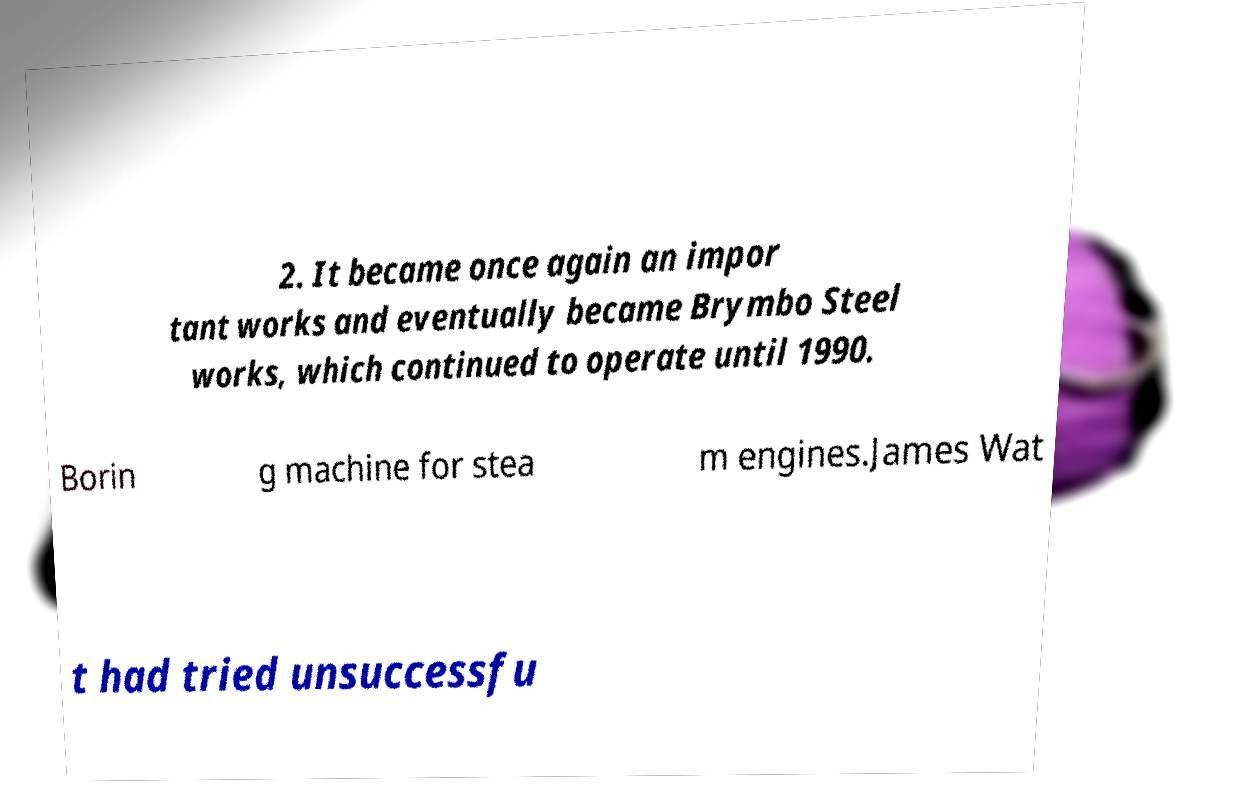Can you read and provide the text displayed in the image?This photo seems to have some interesting text. Can you extract and type it out for me? 2. It became once again an impor tant works and eventually became Brymbo Steel works, which continued to operate until 1990. Borin g machine for stea m engines.James Wat t had tried unsuccessfu 